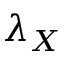<formula> <loc_0><loc_0><loc_500><loc_500>\lambda _ { X }</formula> 